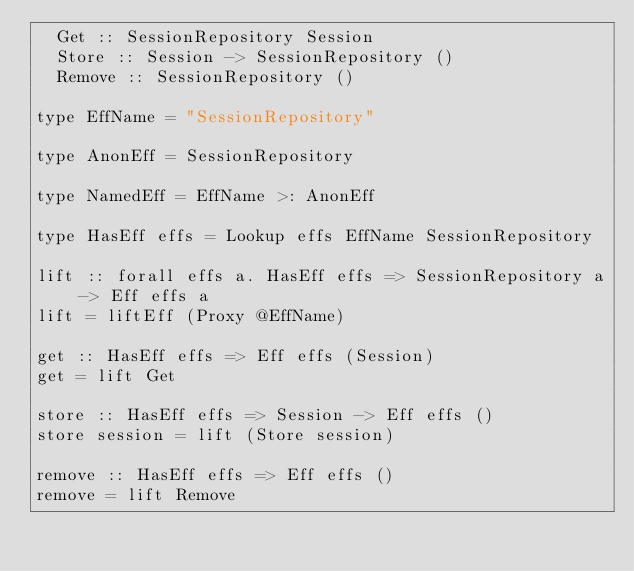Convert code to text. <code><loc_0><loc_0><loc_500><loc_500><_Haskell_>  Get :: SessionRepository Session
  Store :: Session -> SessionRepository ()
  Remove :: SessionRepository ()

type EffName = "SessionRepository"

type AnonEff = SessionRepository

type NamedEff = EffName >: AnonEff

type HasEff effs = Lookup effs EffName SessionRepository

lift :: forall effs a. HasEff effs => SessionRepository a -> Eff effs a
lift = liftEff (Proxy @EffName)

get :: HasEff effs => Eff effs (Session)
get = lift Get

store :: HasEff effs => Session -> Eff effs ()
store session = lift (Store session)

remove :: HasEff effs => Eff effs ()
remove = lift Remove
</code> 